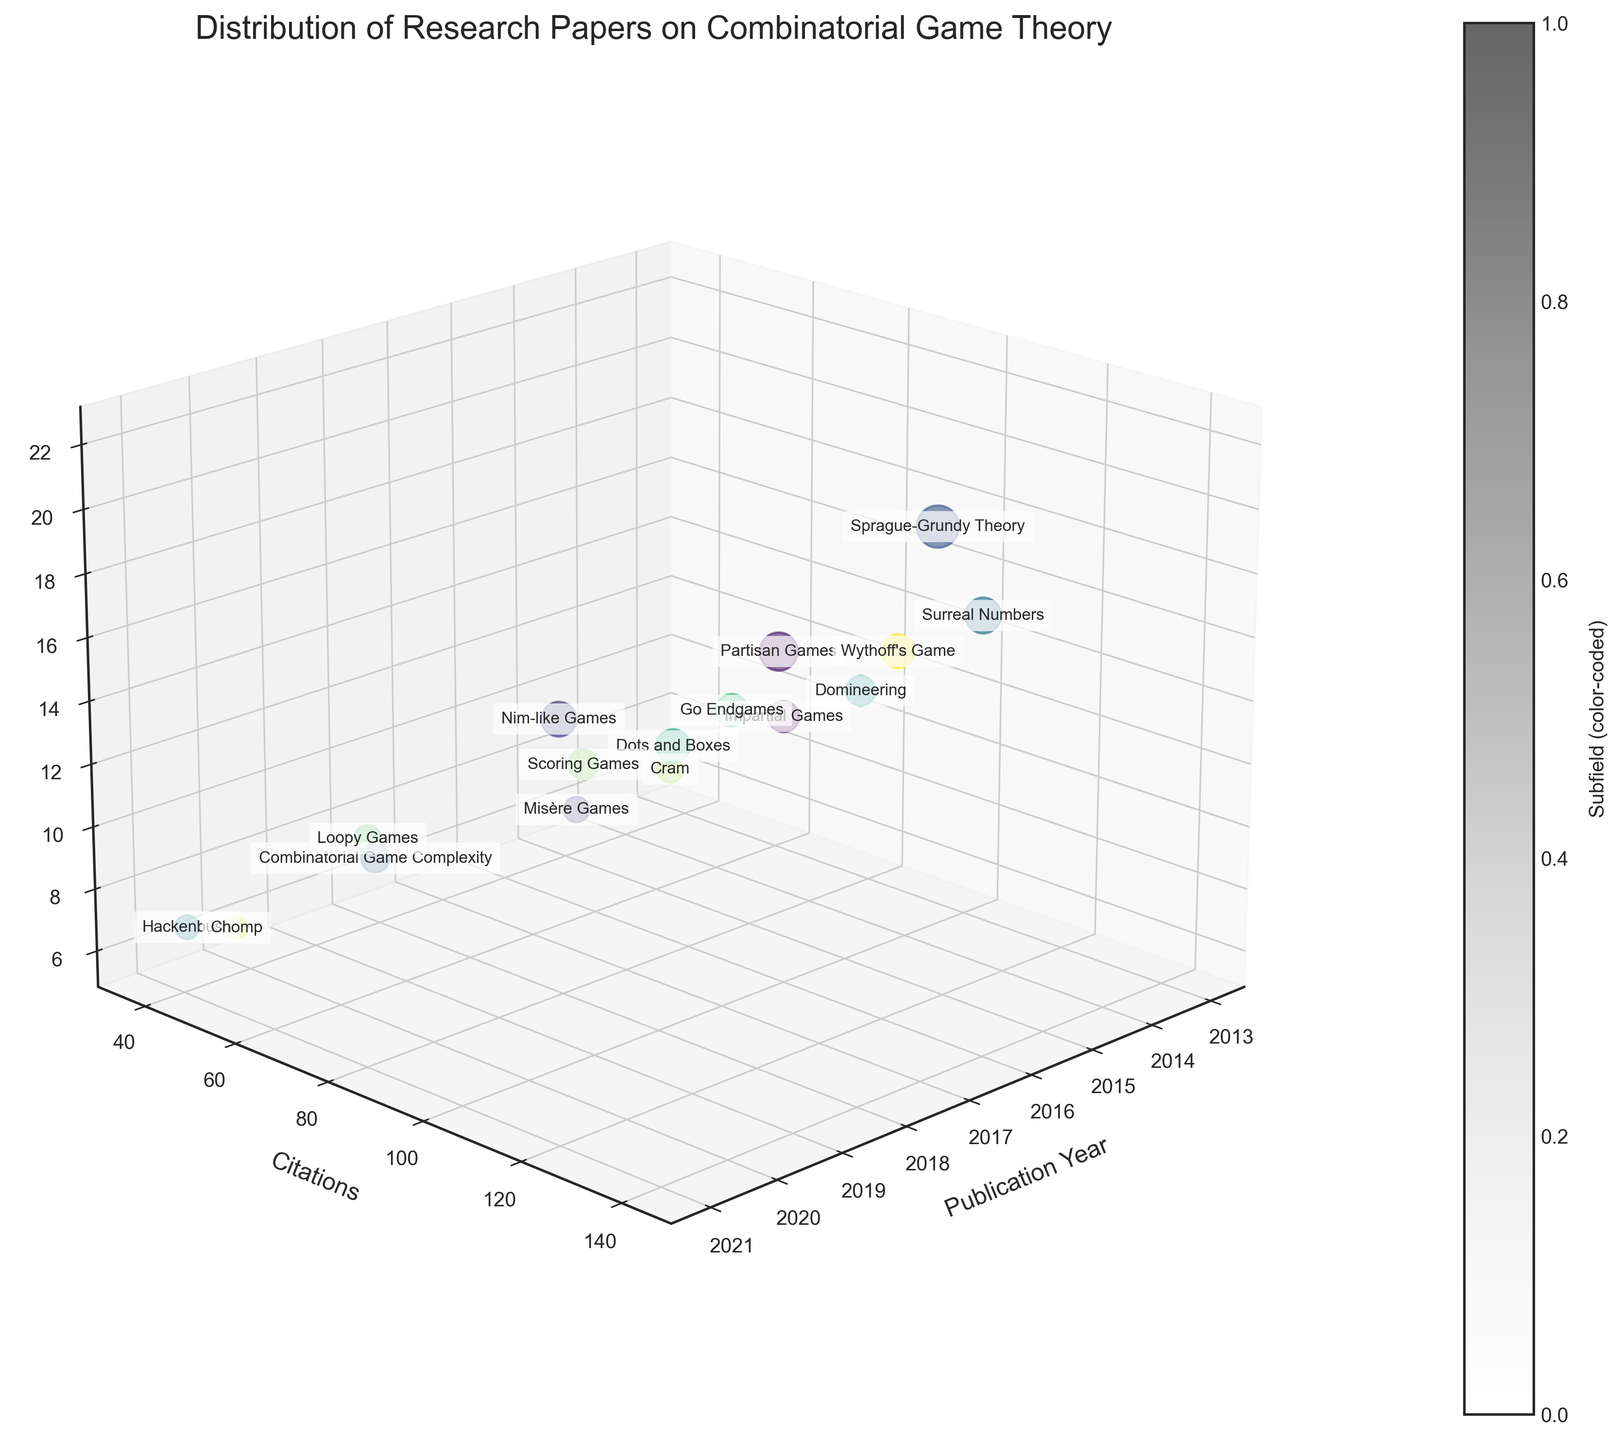What is the title of the figure? The title can be found at the top of the figure, written in a larger font size than the other text elements.
Answer: Distribution of Research Papers on Combinatorial Game Theory Which axis represents the number of citations? The axis labels are usually placed next to the respective axis; the y-axis label in this figure is "Citations."
Answer: y-axis What subfield had the highest number of citations, and what were those citations? By identifying the subfield with the highest point on the y-axis and reading the text next to it. "Sprague-Grundy Theory" is closest to the highest y-axis value, which is 142.
Answer: Sprague-Grundy Theory, 142 How many research papers were published in 2016? Locate all the points along the x-axis where the year is 2016. There are two such points: one is for "Misère Games" with 8 papers, and the other is for "Go Endgames" with 13 papers. Adding these gives 8 + 13 = 21.
Answer: 21 Which subfield has the lowest number of citations, and how many citations does it have? Find the point closest to the lowest y-axis value. The subfield "Chomp" has the lowest citations with a value of 37.
Answer: Chomp, 37 Between 2018 and 2020, which year had the most citations in total? Calculate the total citations for each year: 2018 has 124 (Partisan Games) + 103 (Dots and Boxes) = 227, 2019 has 93 (Nim-like Games) + 52 (Loopy Games) = 145, and 2020 has 68 (Combinatorial Game Complexity) + 37 (Chomp) = 105. 2018 has the highest total.
Answer: 2018 Which subfield has the largest bubble size, and how many papers does it represent? The bubble size is proportional to the number of papers. The largest bubble is labeled "Sprague-Grundy Theory," representing 22 papers.
Answer: Sprague-Grundy Theory, 22 papers How do the citation counts for "Impartial Games" and "Go Endgames" compare? Find the y-axis values for both subfields: "Impartial Games" has 87 citations, and "Go Endgames" has 89. Thus, "Impartial Games" has 2 fewer citations than "Go Endgames."
Answer: "Go Endgames" has 2 more citations than "Impartial Games." What is the average number of citations for papers published in 2019? First, find the citations for papers published in 2019: "Nim-like Games" with 93 citations and "Loopy Games" with 52 citations. Calculate the average (93 + 52) / 2 = 72.5.
Answer: 72.5 Which subfield in 2020 has fewer research papers, and how many papers are there? In 2020, the subfields are "Combinatorial Game Complexity" with 10 papers and "Chomp" with 6 papers. "Chomp" has fewer papers.
Answer: Chomp, 6 papers 